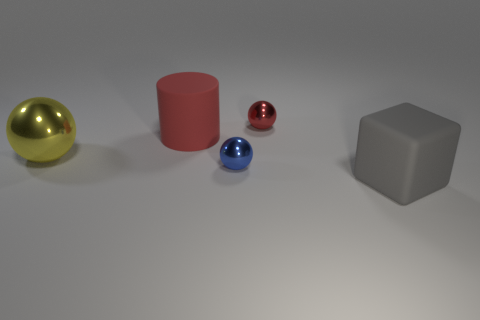Subtract all big yellow shiny spheres. How many spheres are left? 2 Add 5 large cylinders. How many objects exist? 10 Subtract all cubes. How many objects are left? 4 Subtract 2 spheres. How many spheres are left? 1 Subtract all green cylinders. How many cyan spheres are left? 0 Subtract all red matte cubes. Subtract all gray rubber cubes. How many objects are left? 4 Add 5 big shiny balls. How many big shiny balls are left? 6 Add 4 matte blocks. How many matte blocks exist? 5 Subtract 1 red cylinders. How many objects are left? 4 Subtract all cyan cylinders. Subtract all yellow spheres. How many cylinders are left? 1 